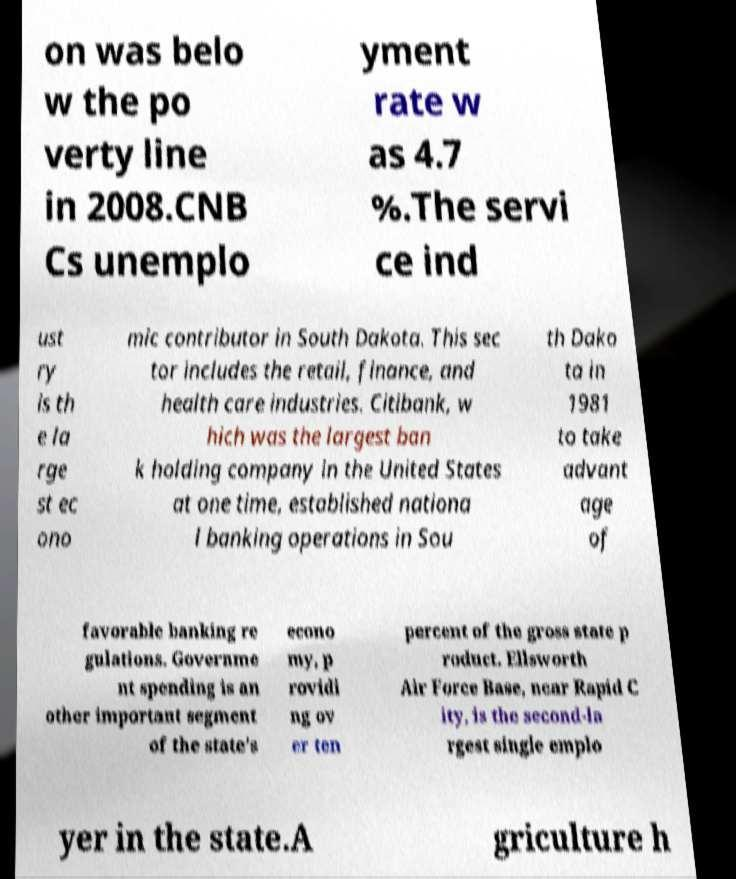Could you extract and type out the text from this image? on was belo w the po verty line in 2008.CNB Cs unemplo yment rate w as 4.7 %.The servi ce ind ust ry is th e la rge st ec ono mic contributor in South Dakota. This sec tor includes the retail, finance, and health care industries. Citibank, w hich was the largest ban k holding company in the United States at one time, established nationa l banking operations in Sou th Dako ta in 1981 to take advant age of favorable banking re gulations. Governme nt spending is an other important segment of the state's econo my, p rovidi ng ov er ten percent of the gross state p roduct. Ellsworth Air Force Base, near Rapid C ity, is the second-la rgest single emplo yer in the state.A griculture h 